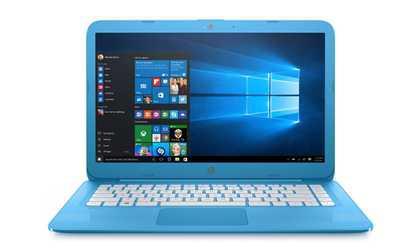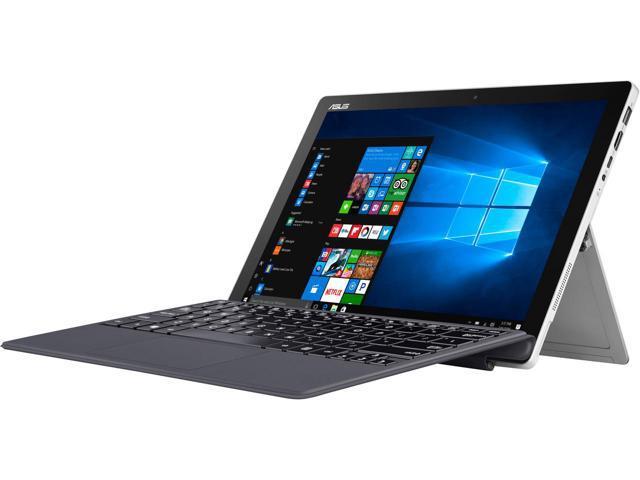The first image is the image on the left, the second image is the image on the right. Considering the images on both sides, is "The right image contains a laptop with a kickstand propping the screen up." valid? Answer yes or no. Yes. The first image is the image on the left, the second image is the image on the right. Evaluate the accuracy of this statement regarding the images: "The laptop on the left is displayed head-on, opened at least at a right angle, and the laptop on the right is displayed at an angle facing leftward.". Is it true? Answer yes or no. Yes. 